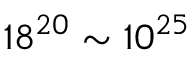Convert formula to latex. <formula><loc_0><loc_0><loc_500><loc_500>1 8 ^ { 2 0 } \sim 1 0 ^ { 2 5 }</formula> 